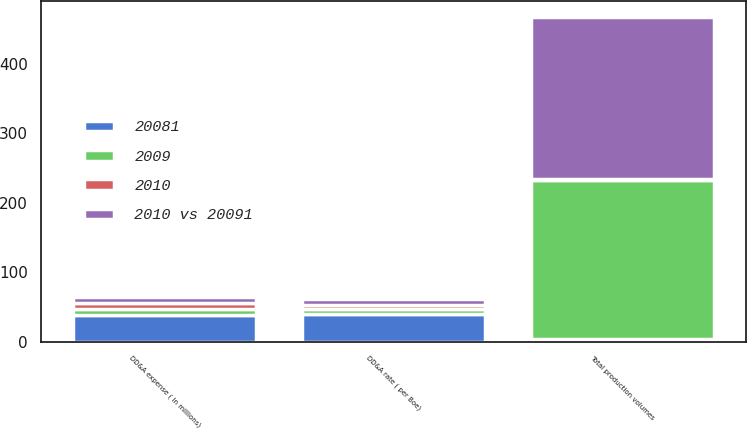Convert chart. <chart><loc_0><loc_0><loc_500><loc_500><stacked_bar_chart><ecel><fcel>Total production volumes<fcel>DD&A rate ( per Boe)<fcel>DD&A expense ( in millions)<nl><fcel>2009<fcel>228<fcel>7.36<fcel>8.43<nl><fcel>2010<fcel>2<fcel>6<fcel>9<nl><fcel>2010 vs 20091<fcel>233<fcel>7.86<fcel>8.43<nl><fcel>20081<fcel>4<fcel>40<fcel>38<nl></chart> 